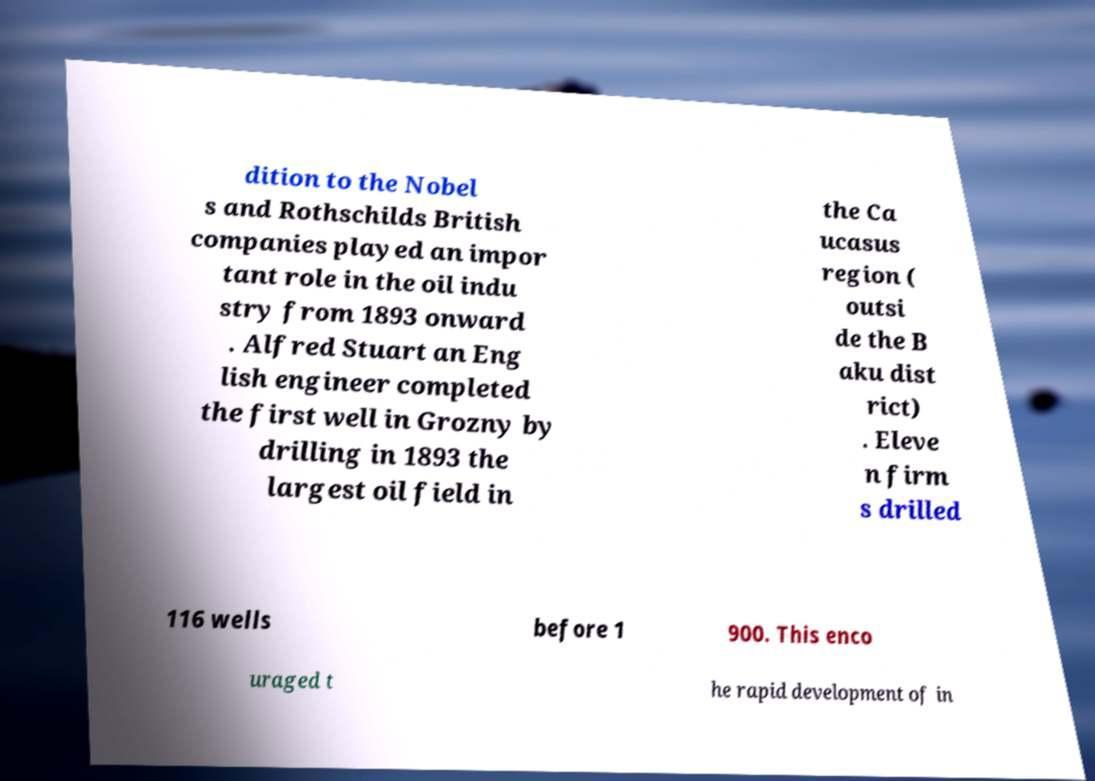Can you accurately transcribe the text from the provided image for me? dition to the Nobel s and Rothschilds British companies played an impor tant role in the oil indu stry from 1893 onward . Alfred Stuart an Eng lish engineer completed the first well in Grozny by drilling in 1893 the largest oil field in the Ca ucasus region ( outsi de the B aku dist rict) . Eleve n firm s drilled 116 wells before 1 900. This enco uraged t he rapid development of in 